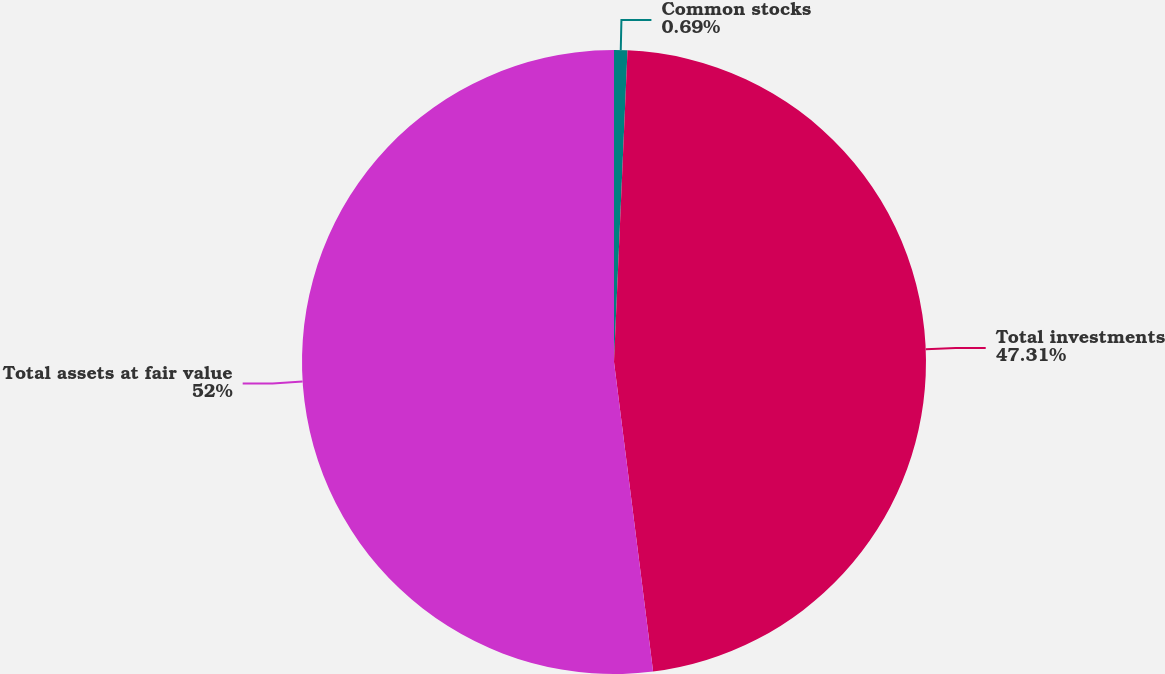<chart> <loc_0><loc_0><loc_500><loc_500><pie_chart><fcel>Common stocks<fcel>Total investments<fcel>Total assets at fair value<nl><fcel>0.69%<fcel>47.31%<fcel>52.0%<nl></chart> 